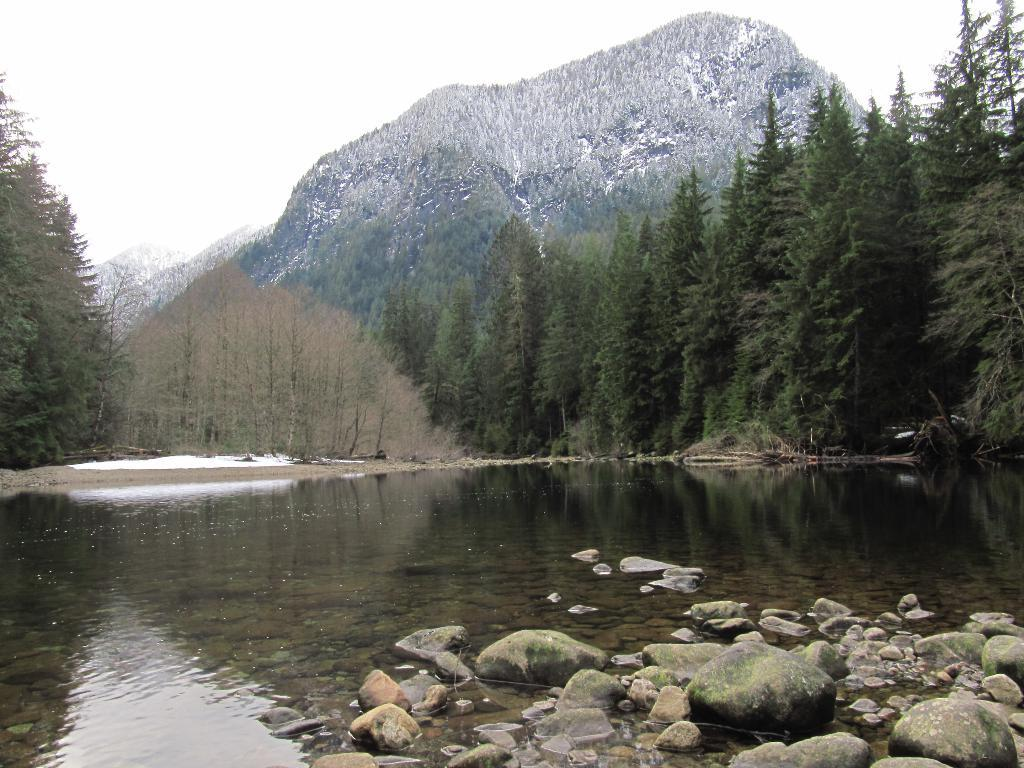What is the primary element in the image? There is water in the image. What other objects can be seen in the image? There are stones in the image. What can be seen in the background of the image? There are trees and mountains in the background of the image, and the sky is visible as well. What type of coal can be seen in the image? There is no coal present in the image. What kind of humor is depicted in the image? The image does not contain any humor; it features water, stones, trees, mountains, and the sky. 